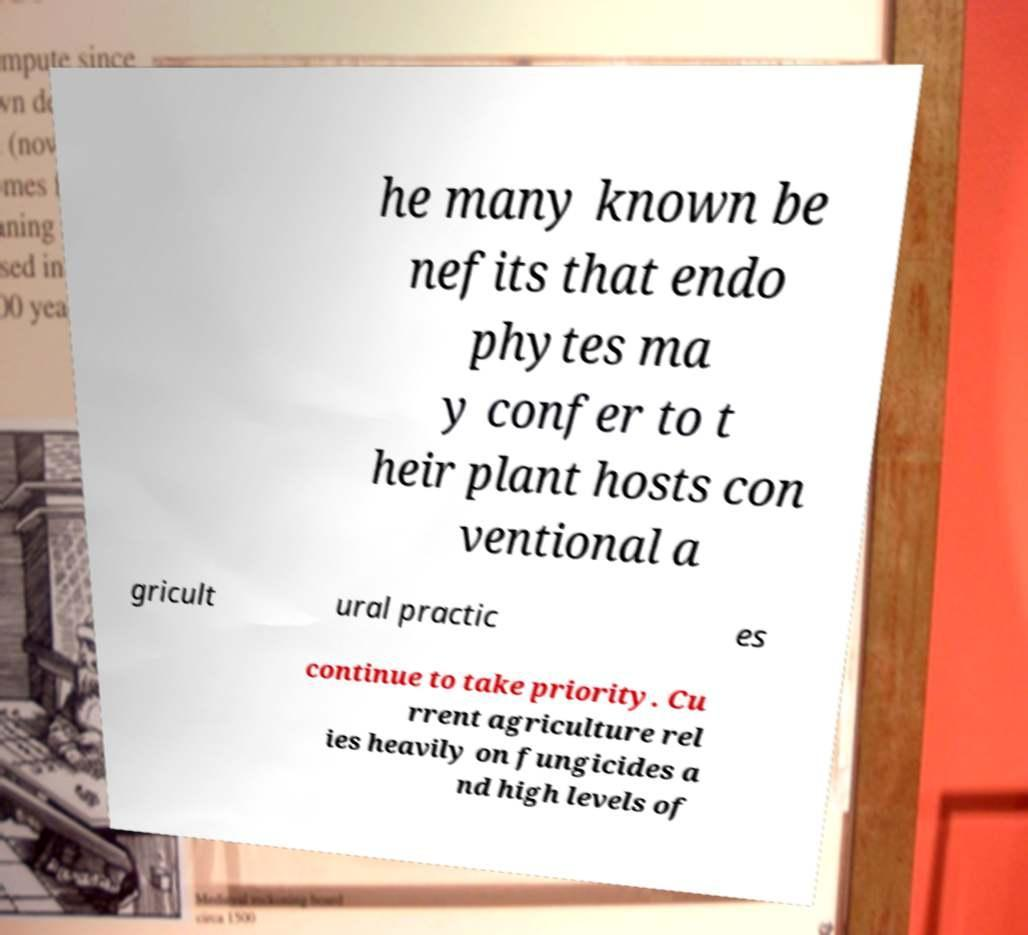For documentation purposes, I need the text within this image transcribed. Could you provide that? he many known be nefits that endo phytes ma y confer to t heir plant hosts con ventional a gricult ural practic es continue to take priority. Cu rrent agriculture rel ies heavily on fungicides a nd high levels of 